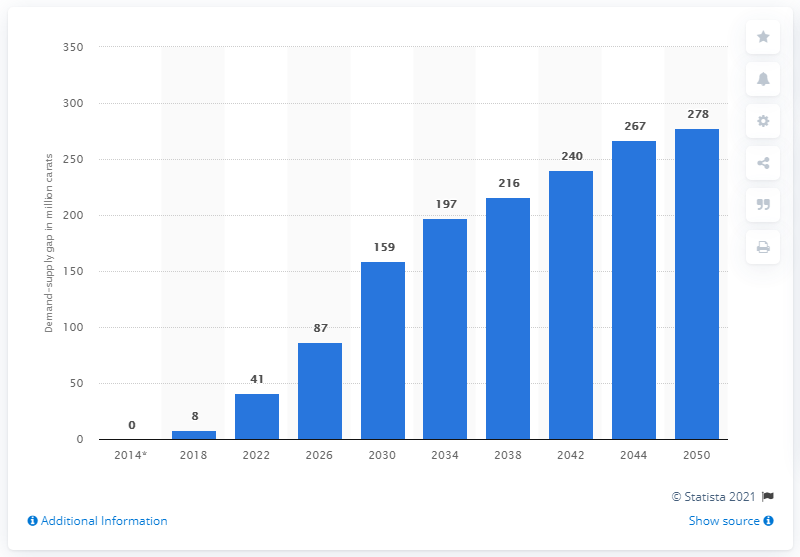Point out several critical features in this image. By 2050, it is predicted that there will be a global demand-supply shortfall of rough diamonds, estimated to be approximately 278 million carats. 